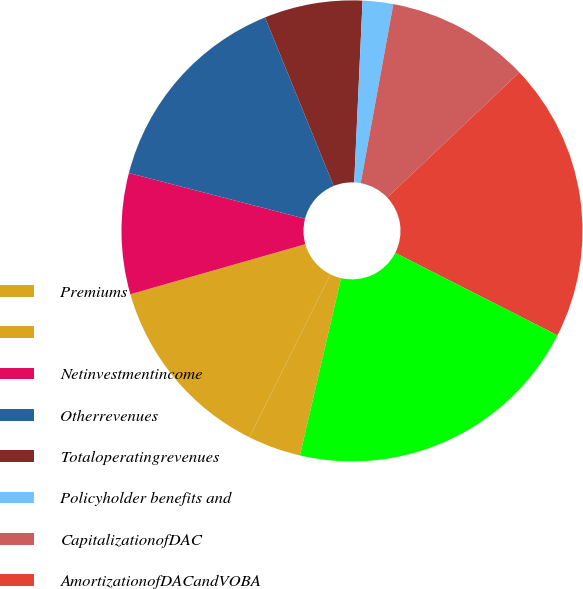<chart> <loc_0><loc_0><loc_500><loc_500><pie_chart><fcel>Premiums<fcel>Unnamed: 1<fcel>Netinvestmentincome<fcel>Otherrevenues<fcel>Totaloperatingrevenues<fcel>Policyholder benefits and<fcel>CapitalizationofDAC<fcel>AmortizationofDACandVOBA<fcel>Interestexpense<nl><fcel>3.72%<fcel>13.22%<fcel>8.47%<fcel>14.8%<fcel>6.89%<fcel>2.14%<fcel>10.06%<fcel>19.55%<fcel>21.14%<nl></chart> 